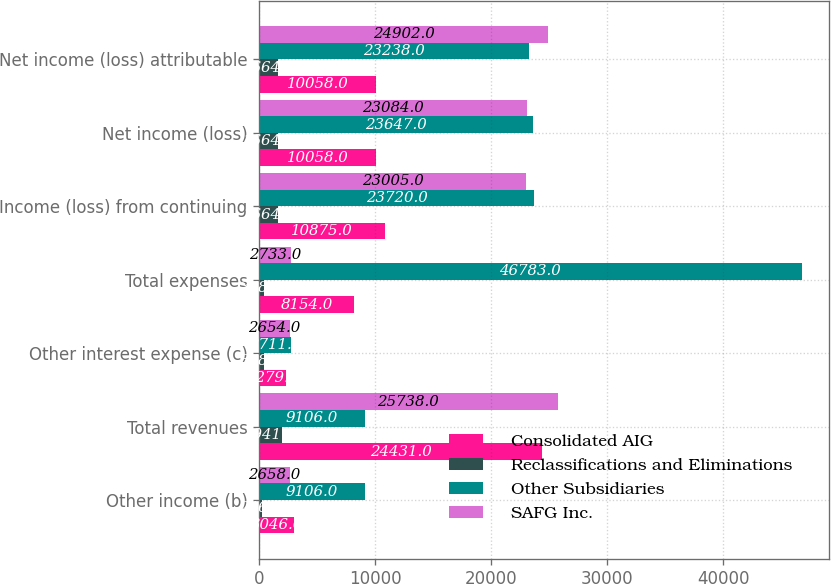<chart> <loc_0><loc_0><loc_500><loc_500><stacked_bar_chart><ecel><fcel>Other income (b)<fcel>Total revenues<fcel>Other interest expense (c)<fcel>Total expenses<fcel>Income (loss) from continuing<fcel>Net income (loss)<fcel>Net income (loss) attributable<nl><fcel>Consolidated AIG<fcel>3046<fcel>24431<fcel>2279<fcel>8154<fcel>10875<fcel>10058<fcel>10058<nl><fcel>Reclassifications and Eliminations<fcel>246<fcel>1941<fcel>378<fcel>378<fcel>1664<fcel>1664<fcel>1664<nl><fcel>Other Subsidiaries<fcel>9106<fcel>9106<fcel>2711<fcel>46783<fcel>23720<fcel>23647<fcel>23238<nl><fcel>SAFG Inc.<fcel>2658<fcel>25738<fcel>2654<fcel>2733<fcel>23005<fcel>23084<fcel>24902<nl></chart> 